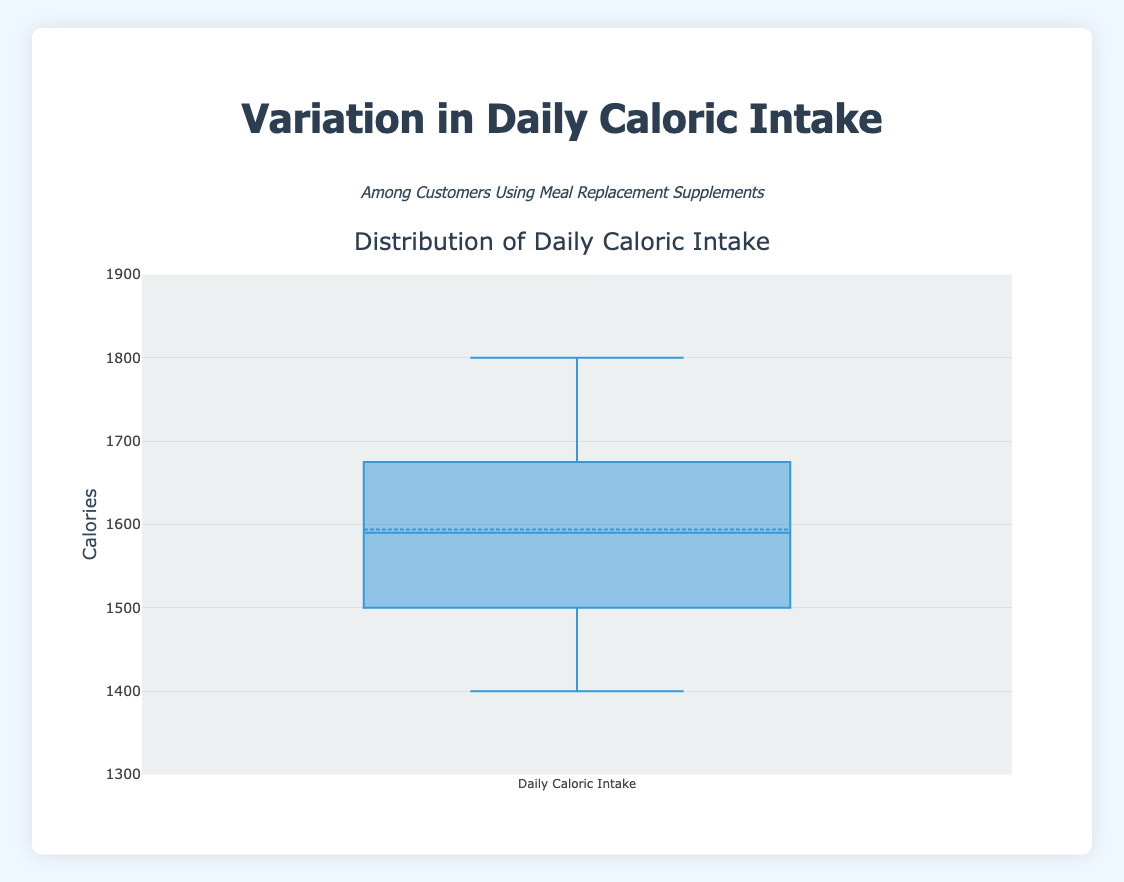What's the title of the box plot? The title of a plot is typically displayed at the top of the graph. For this plot, it's clearly specified.
Answer: Distribution of Daily Caloric Intake What is the range of the y-axis? The y-axis range is shown at the left side of the plot. It's set between two specific values to encompass all the data points.
Answer: 1300 to 1900 Which color represents the box plot? Box plot color can be identified by looking at the box plot itself. Here it's clearly marked with a specific visual color.
Answer: Blue What's the median value of daily caloric intake among customers? The median value in a box plot is represented by the line inside the box. From the plot, this line is at a specific caloric value.
Answer: 1600 What's the interquartile range (IQR) of the daily caloric intake? The IQR is determined by the difference between the 75th percentile (top of the box) and the 25th percentile (bottom of the box). The box plot shows this directly.
Answer: 150 What's the maximum caloric intake observed among customers? The maximum value in a box plot is represented by the topmost whisker or outlier. This is easily read from the plot.
Answer: 1800 What's the minimum caloric intake observed among customers? The minimum value in a box plot is represented by the bottommost whisker or outlier. This is visible in the plot.
Answer: 1400 How many customers have a caloric intake within the interquartile range? In a box plot, the interquartile range covers the middle 50% of the data. Hence, half of 20 customers fall within this range.
Answer: 10 What's the average caloric intake if we consider the entire dataset? The average can be inferred since the box plot indicates the mean, which is usually marked distinctly (e.g., with a dot). The mean value is directly reading from the plot.
Answer: ~1600 Is there a customer with an intake significantly lower or higher than the rest? Significant outliers are often highlighted in box plots. Here, outliers must fall beyond whiskers indicating very high or low values relative to the rest of the data.
Answer: No 